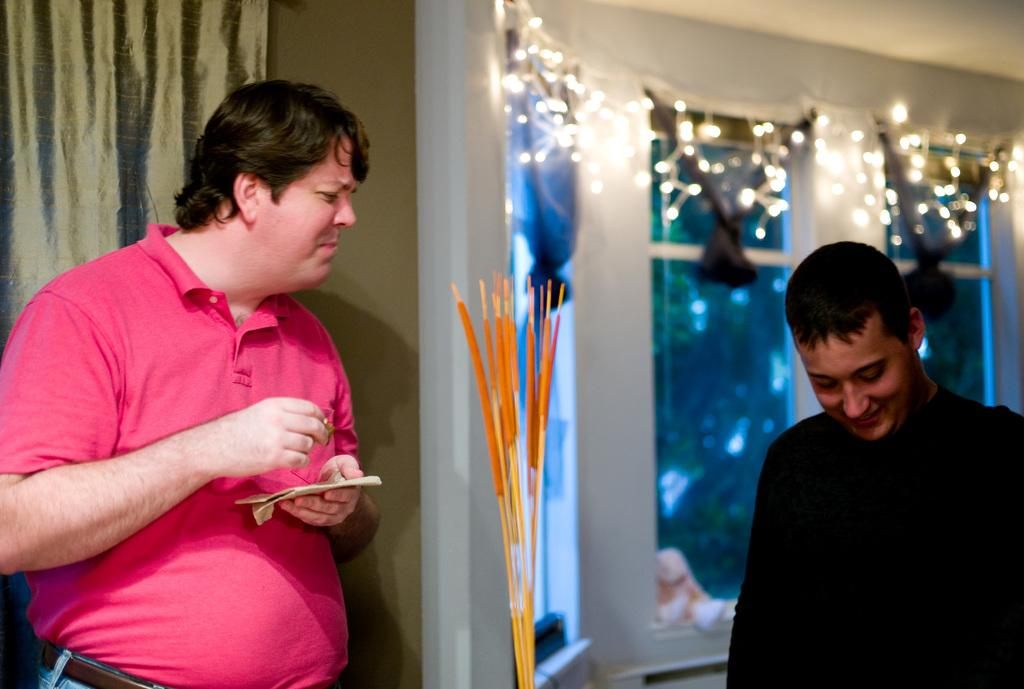How many people are present in the image? There are two men in the image. What is the second person holding? The second person is holding some paper. What can be seen in the background of the image? There are windows and lights visible between the windows in the background. What type of error can be seen on the sun in the image? There is no sun present in the image, and therefore no errors can be observed on it. 